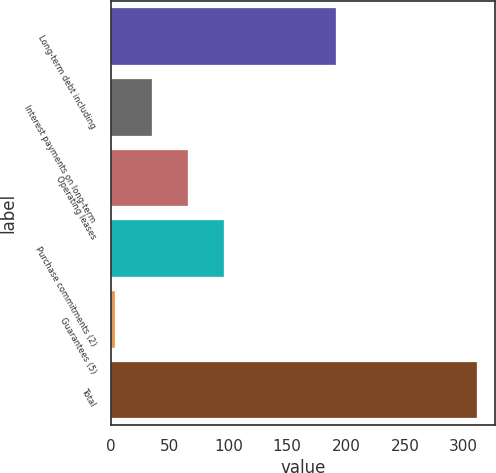Convert chart. <chart><loc_0><loc_0><loc_500><loc_500><bar_chart><fcel>Long-term debt including<fcel>Interest payments on long-term<fcel>Operating leases<fcel>Purchase commitments (2)<fcel>Guarantees (5)<fcel>Total<nl><fcel>191.8<fcel>34.83<fcel>65.56<fcel>96.29<fcel>4.1<fcel>311.4<nl></chart> 